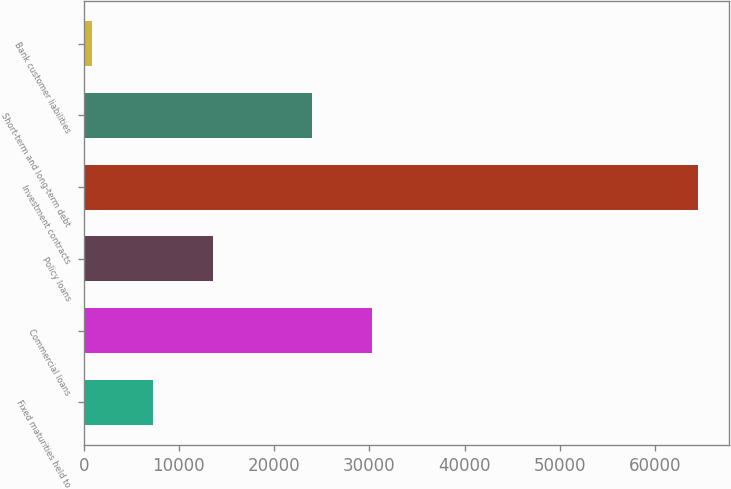<chart> <loc_0><loc_0><loc_500><loc_500><bar_chart><fcel>Fixed maturities held to<fcel>Commercial loans<fcel>Policy loans<fcel>Investment contracts<fcel>Short-term and long-term debt<fcel>Bank customer liabilities<nl><fcel>7264.5<fcel>30320.5<fcel>13626<fcel>64518<fcel>23959<fcel>903<nl></chart> 